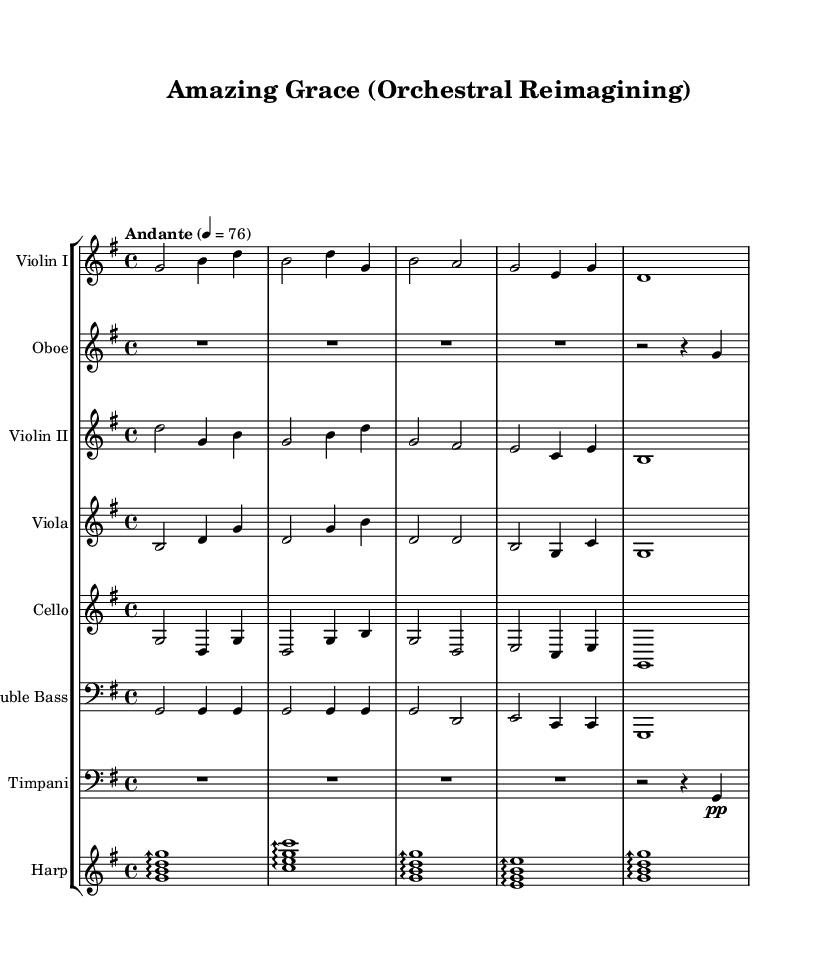what is the key signature of this music? The key signature is indicated at the beginning of the sheet music, showing one sharp, which corresponds to the G major scale.
Answer: G major what is the time signature of this music? The time signature is found after the key signature, and it is 4/4, meaning there are four beats in each measure and the quarter note gets one beat.
Answer: 4/4 what is the tempo marking of this music? The tempo marking is written above the staff and indicates "Andante" with a quarter note equals 76, meaning the piece should be played at a moderate speed.
Answer: Andante, 76 how many instrumental parts are used in this arrangement? By counting the individual staves within the score, there are a total of seven distinct instrumental parts listed: Violin I, Oboe, Violin II, Viola, Cello, Double Bass, Timpani, and Harp.
Answer: Seven which string instrument plays the melody in this arrangement? Observing the melodic lines in the score, Violin I primarily carries the main melody throughout the orchestral arrangement, making it the focal point for the piece.
Answer: Violin I what role does the harp play in this music? The harp is featured as an arpeggiated accompaniment, providing harmonic support with specific chord structures outlined in the sheet music, emphasizing a delicate, flowing texture.
Answer: Arpeggiated accompaniment which measure contains a rest for the timpani? Looking at the timpani part, it shows a rest in the first measure, indicating silence before it plays the rhythm starting in the second measure.
Answer: First measure 